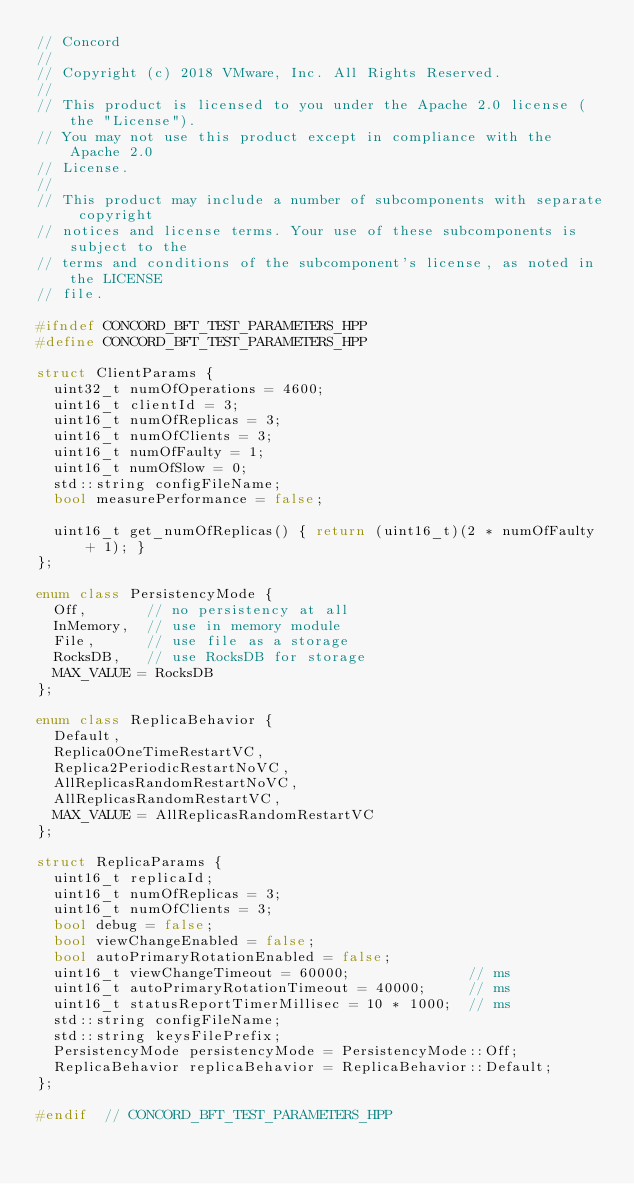Convert code to text. <code><loc_0><loc_0><loc_500><loc_500><_C++_>// Concord
//
// Copyright (c) 2018 VMware, Inc. All Rights Reserved.
//
// This product is licensed to you under the Apache 2.0 license (the "License").
// You may not use this product except in compliance with the Apache 2.0
// License.
//
// This product may include a number of subcomponents with separate copyright
// notices and license terms. Your use of these subcomponents is subject to the
// terms and conditions of the subcomponent's license, as noted in the LICENSE
// file.

#ifndef CONCORD_BFT_TEST_PARAMETERS_HPP
#define CONCORD_BFT_TEST_PARAMETERS_HPP

struct ClientParams {
  uint32_t numOfOperations = 4600;
  uint16_t clientId = 3;
  uint16_t numOfReplicas = 3;
  uint16_t numOfClients = 3;
  uint16_t numOfFaulty = 1;
  uint16_t numOfSlow = 0;
  std::string configFileName;
  bool measurePerformance = false;

  uint16_t get_numOfReplicas() { return (uint16_t)(2 * numOfFaulty + 1); }
};

enum class PersistencyMode {
  Off,       // no persistency at all
  InMemory,  // use in memory module
  File,      // use file as a storage
  RocksDB,   // use RocksDB for storage
  MAX_VALUE = RocksDB
};

enum class ReplicaBehavior {
  Default,
  Replica0OneTimeRestartVC,
  Replica2PeriodicRestartNoVC,
  AllReplicasRandomRestartNoVC,
  AllReplicasRandomRestartVC,
  MAX_VALUE = AllReplicasRandomRestartVC
};

struct ReplicaParams {
  uint16_t replicaId;
  uint16_t numOfReplicas = 3;
  uint16_t numOfClients = 3;
  bool debug = false;
  bool viewChangeEnabled = false;
  bool autoPrimaryRotationEnabled = false;
  uint16_t viewChangeTimeout = 60000;              // ms
  uint16_t autoPrimaryRotationTimeout = 40000;     // ms
  uint16_t statusReportTimerMillisec = 10 * 1000;  // ms
  std::string configFileName;
  std::string keysFilePrefix;
  PersistencyMode persistencyMode = PersistencyMode::Off;
  ReplicaBehavior replicaBehavior = ReplicaBehavior::Default;
};

#endif  // CONCORD_BFT_TEST_PARAMETERS_HPP
</code> 